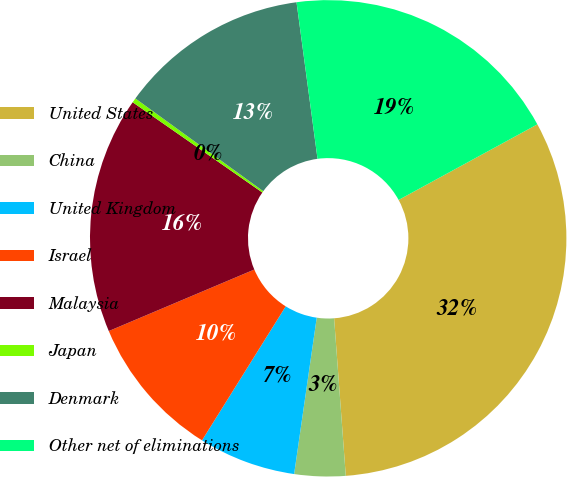Convert chart to OTSL. <chart><loc_0><loc_0><loc_500><loc_500><pie_chart><fcel>United States<fcel>China<fcel>United Kingdom<fcel>Israel<fcel>Malaysia<fcel>Japan<fcel>Denmark<fcel>Other net of eliminations<nl><fcel>31.76%<fcel>3.46%<fcel>6.6%<fcel>9.75%<fcel>16.04%<fcel>0.31%<fcel>12.89%<fcel>19.18%<nl></chart> 